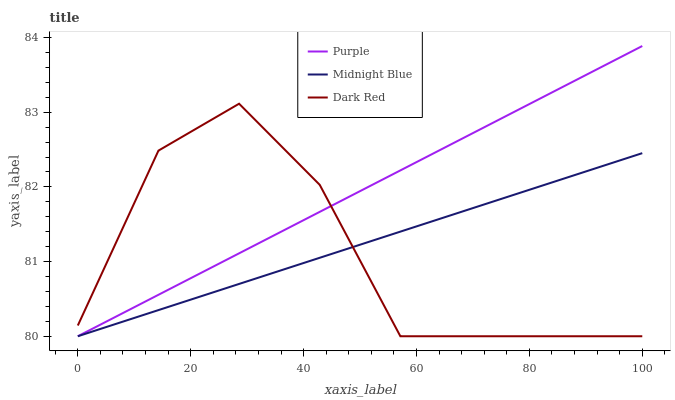Does Dark Red have the minimum area under the curve?
Answer yes or no. Yes. Does Purple have the maximum area under the curve?
Answer yes or no. Yes. Does Midnight Blue have the minimum area under the curve?
Answer yes or no. No. Does Midnight Blue have the maximum area under the curve?
Answer yes or no. No. Is Midnight Blue the smoothest?
Answer yes or no. Yes. Is Dark Red the roughest?
Answer yes or no. Yes. Is Dark Red the smoothest?
Answer yes or no. No. Is Midnight Blue the roughest?
Answer yes or no. No. Does Dark Red have the highest value?
Answer yes or no. No. 